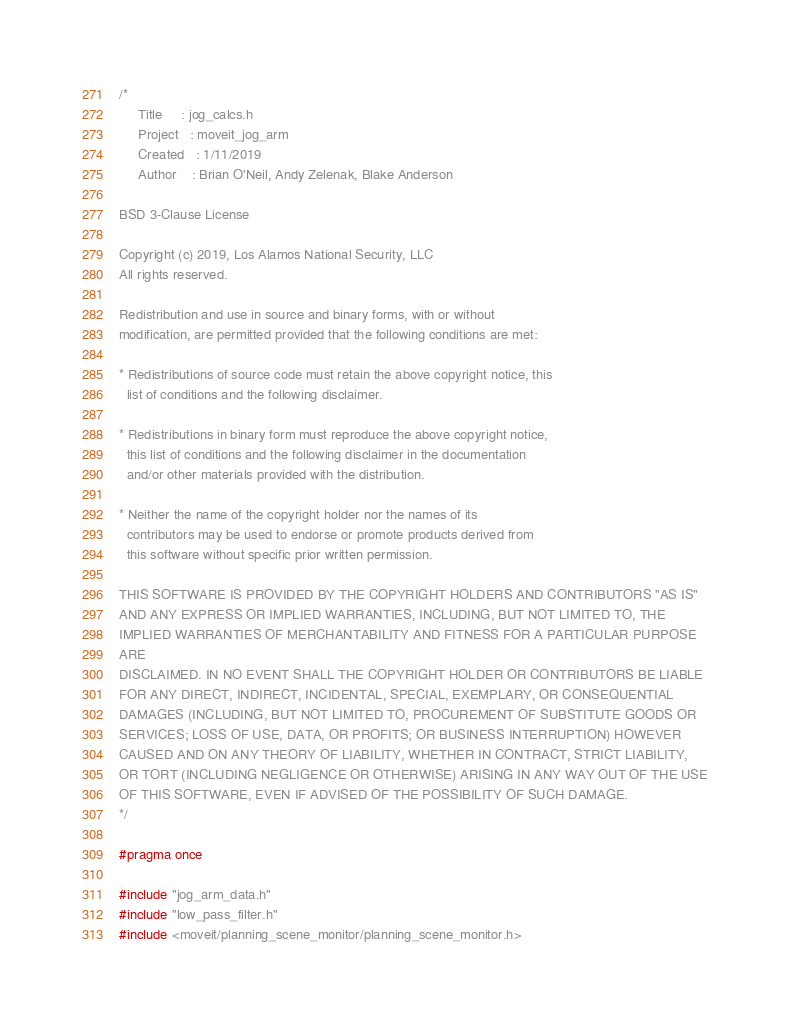<code> <loc_0><loc_0><loc_500><loc_500><_C_>/*
     Title     : jog_calcs.h
     Project   : moveit_jog_arm
     Created   : 1/11/2019
     Author    : Brian O'Neil, Andy Zelenak, Blake Anderson

BSD 3-Clause License

Copyright (c) 2019, Los Alamos National Security, LLC
All rights reserved.

Redistribution and use in source and binary forms, with or without
modification, are permitted provided that the following conditions are met:

* Redistributions of source code must retain the above copyright notice, this
  list of conditions and the following disclaimer.

* Redistributions in binary form must reproduce the above copyright notice,
  this list of conditions and the following disclaimer in the documentation
  and/or other materials provided with the distribution.

* Neither the name of the copyright holder nor the names of its
  contributors may be used to endorse or promote products derived from
  this software without specific prior written permission.

THIS SOFTWARE IS PROVIDED BY THE COPYRIGHT HOLDERS AND CONTRIBUTORS "AS IS"
AND ANY EXPRESS OR IMPLIED WARRANTIES, INCLUDING, BUT NOT LIMITED TO, THE
IMPLIED WARRANTIES OF MERCHANTABILITY AND FITNESS FOR A PARTICULAR PURPOSE
ARE
DISCLAIMED. IN NO EVENT SHALL THE COPYRIGHT HOLDER OR CONTRIBUTORS BE LIABLE
FOR ANY DIRECT, INDIRECT, INCIDENTAL, SPECIAL, EXEMPLARY, OR CONSEQUENTIAL
DAMAGES (INCLUDING, BUT NOT LIMITED TO, PROCUREMENT OF SUBSTITUTE GOODS OR
SERVICES; LOSS OF USE, DATA, OR PROFITS; OR BUSINESS INTERRUPTION) HOWEVER
CAUSED AND ON ANY THEORY OF LIABILITY, WHETHER IN CONTRACT, STRICT LIABILITY,
OR TORT (INCLUDING NEGLIGENCE OR OTHERWISE) ARISING IN ANY WAY OUT OF THE USE
OF THIS SOFTWARE, EVEN IF ADVISED OF THE POSSIBILITY OF SUCH DAMAGE.
*/

#pragma once

#include "jog_arm_data.h"
#include "low_pass_filter.h"
#include <moveit/planning_scene_monitor/planning_scene_monitor.h></code> 